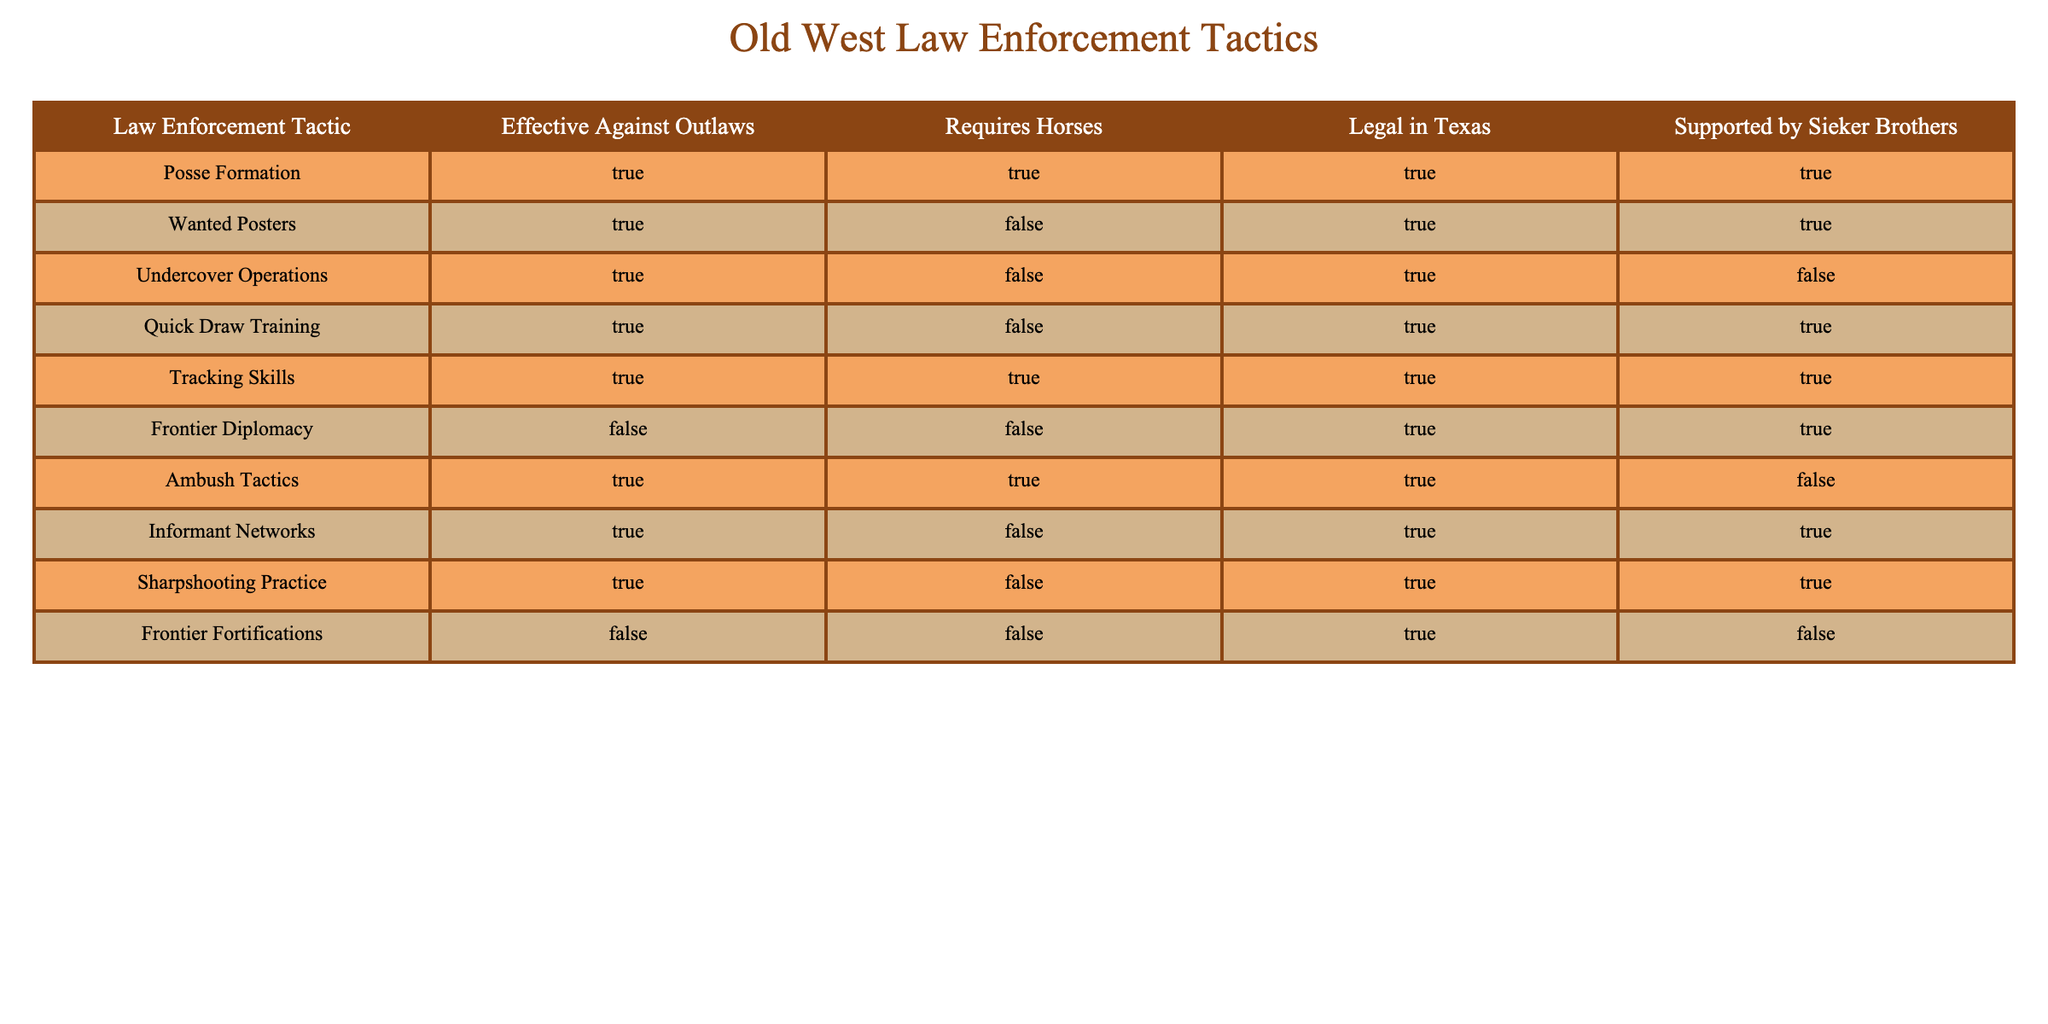What law enforcement tactic is effective against outlaws and requires horses? By examining the table, we look for tactics with "TRUE" under both "Effective Against Outlaws" and "Requires Horses." The tactics that meet both criteria are Posse Formation, Tracking Skills, and Ambush Tactics.
Answer: Posse Formation, Tracking Skills, Ambush Tactics Which law enforcement tactic is NOT supported by the Sieker Brothers? To identify tactics not supported by the Sieker Brothers, we need to check which rows have "FALSE" in the "Supported by Sieker Brothers" column. The tactics that are not supported are Undercover Operations, Ambush Tactics, Frontier Fortifications.
Answer: Undercover Operations, Ambush Tactics, Frontier Fortifications How many tactics that are effective against outlaws require horses? We count the number of tactics listed as "TRUE" under both "Effective Against Outlaws" and "Requires Horses." The relevant tactics are Posse Formation, Tracking Skills, and Ambush Tactics—totaling three.
Answer: 3 Are Wanted Posters legal in Texas? By consulting the table, we can see that "Wanted Posters" have "TRUE" under "Legal in Texas," indicating they are legal.
Answer: Yes Which tactics are effective against outlaws but do not require horses? We inspect the table for tactics where "Effective Against Outlaws" is "TRUE" and "Requires Horses" is "FALSE." The tactics fitting this description are Wanted Posters, Undercover Operations, Quick Draw Training, Informant Networks, and Sharpshooting Practice.
Answer: Wanted Posters, Undercover Operations, Quick Draw Training, Informant Networks, Sharpshooting Practice Are all law enforcement tactics requiring horses also effective against outlaws? We check the "Requires Horses" column for "TRUE" and see if they all have "TRUE" under "Effective Against Outlaws." By reviewing the rows, we find that Ambush Tactics is "TRUE" for horses but not supported against outlaws. Hence, not all tactics requiring horses are effective.
Answer: No What is the total number of tactics listed in the table? By counting the number of rows in the table, we find there are ten tactics provided.
Answer: 10 How many tactics are effective against outlaws and supported by the Sieker Brothers? To find this, we look for tactics where both "Effective Against Outlaws" and "Supported by Sieker Brothers" are "TRUE." These tactics are Posse Formation, Wanted Posters, Quick Draw Training, Tracking Skills, and Informant Networks. Thus, there are five tactics.
Answer: 5 Which tactic has a false response for both legal in Texas and supported by the Sieker Brothers? We look for rows where "Legal in Texas" and "Supported by Sieker Brothers" both have "FALSE." The tactic that meets this criteria is Frontier Fortifications.
Answer: Frontier Fortifications 